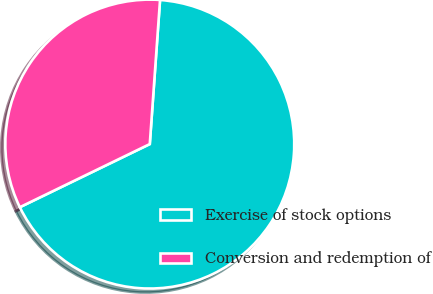Convert chart to OTSL. <chart><loc_0><loc_0><loc_500><loc_500><pie_chart><fcel>Exercise of stock options<fcel>Conversion and redemption of<nl><fcel>66.67%<fcel>33.33%<nl></chart> 